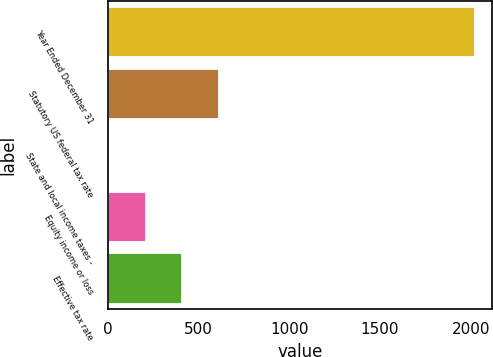Convert chart to OTSL. <chart><loc_0><loc_0><loc_500><loc_500><bar_chart><fcel>Year Ended December 31<fcel>Statutory US federal tax rate<fcel>State and local income taxes -<fcel>Equity income or loss<fcel>Effective tax rate<nl><fcel>2018<fcel>606.45<fcel>1.5<fcel>203.15<fcel>404.8<nl></chart> 